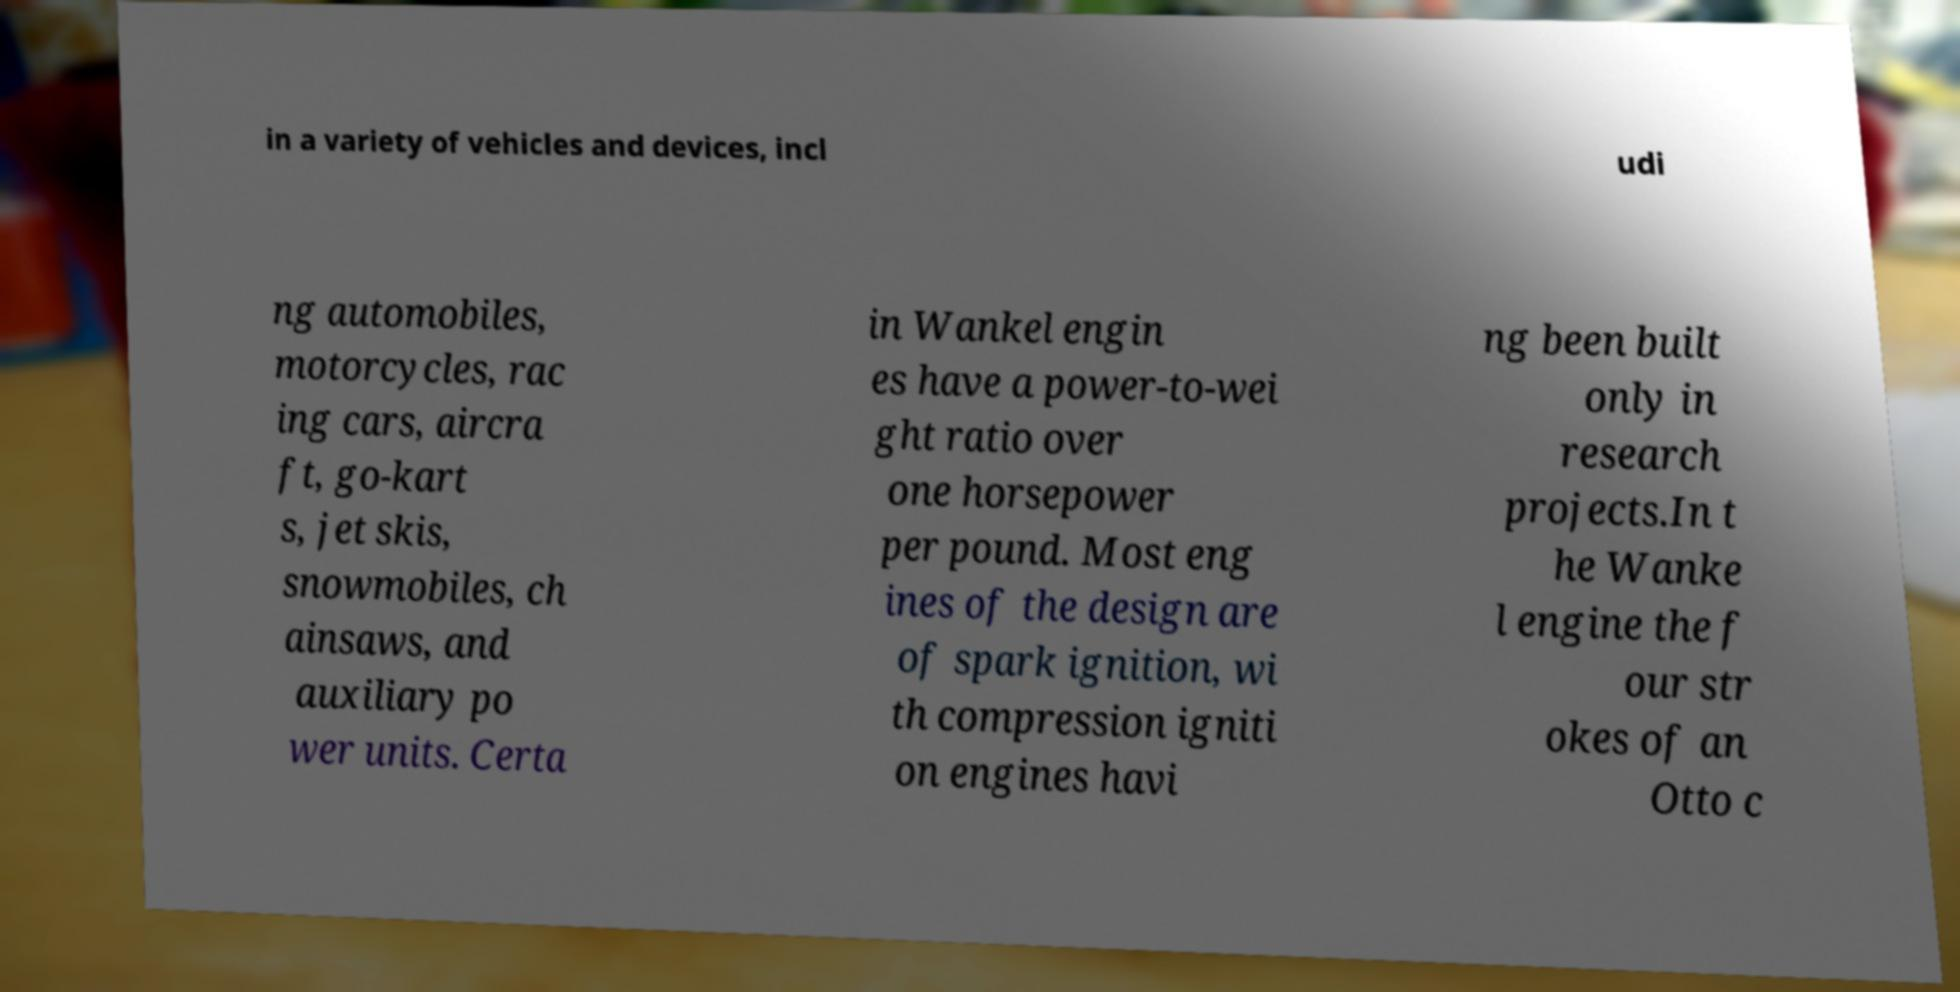Could you extract and type out the text from this image? in a variety of vehicles and devices, incl udi ng automobiles, motorcycles, rac ing cars, aircra ft, go-kart s, jet skis, snowmobiles, ch ainsaws, and auxiliary po wer units. Certa in Wankel engin es have a power-to-wei ght ratio over one horsepower per pound. Most eng ines of the design are of spark ignition, wi th compression igniti on engines havi ng been built only in research projects.In t he Wanke l engine the f our str okes of an Otto c 